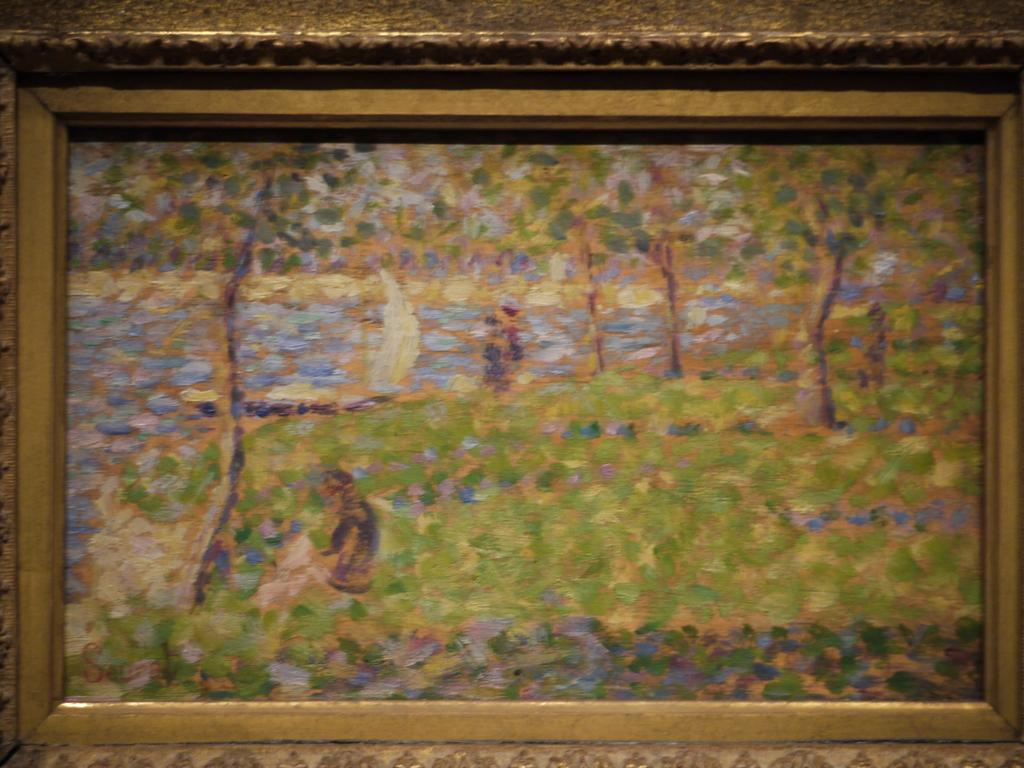What object is present in the image that typically holds a picture or artwork? There is a photo frame in the image. What is displayed within the photo frame? The photo frame contains a painting. What type of shirt is visible in the painting within the photo frame? There is no shirt visible in the painting within the photo frame, as the facts provided do not mention any clothing or specific details about the painting. 